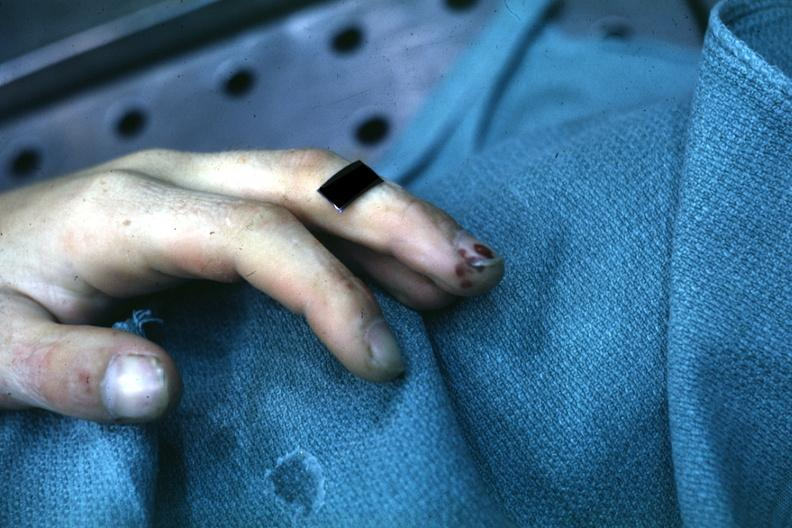what shown on index finger staphylococcus?
Answer the question using a single word or phrase. Lesions 